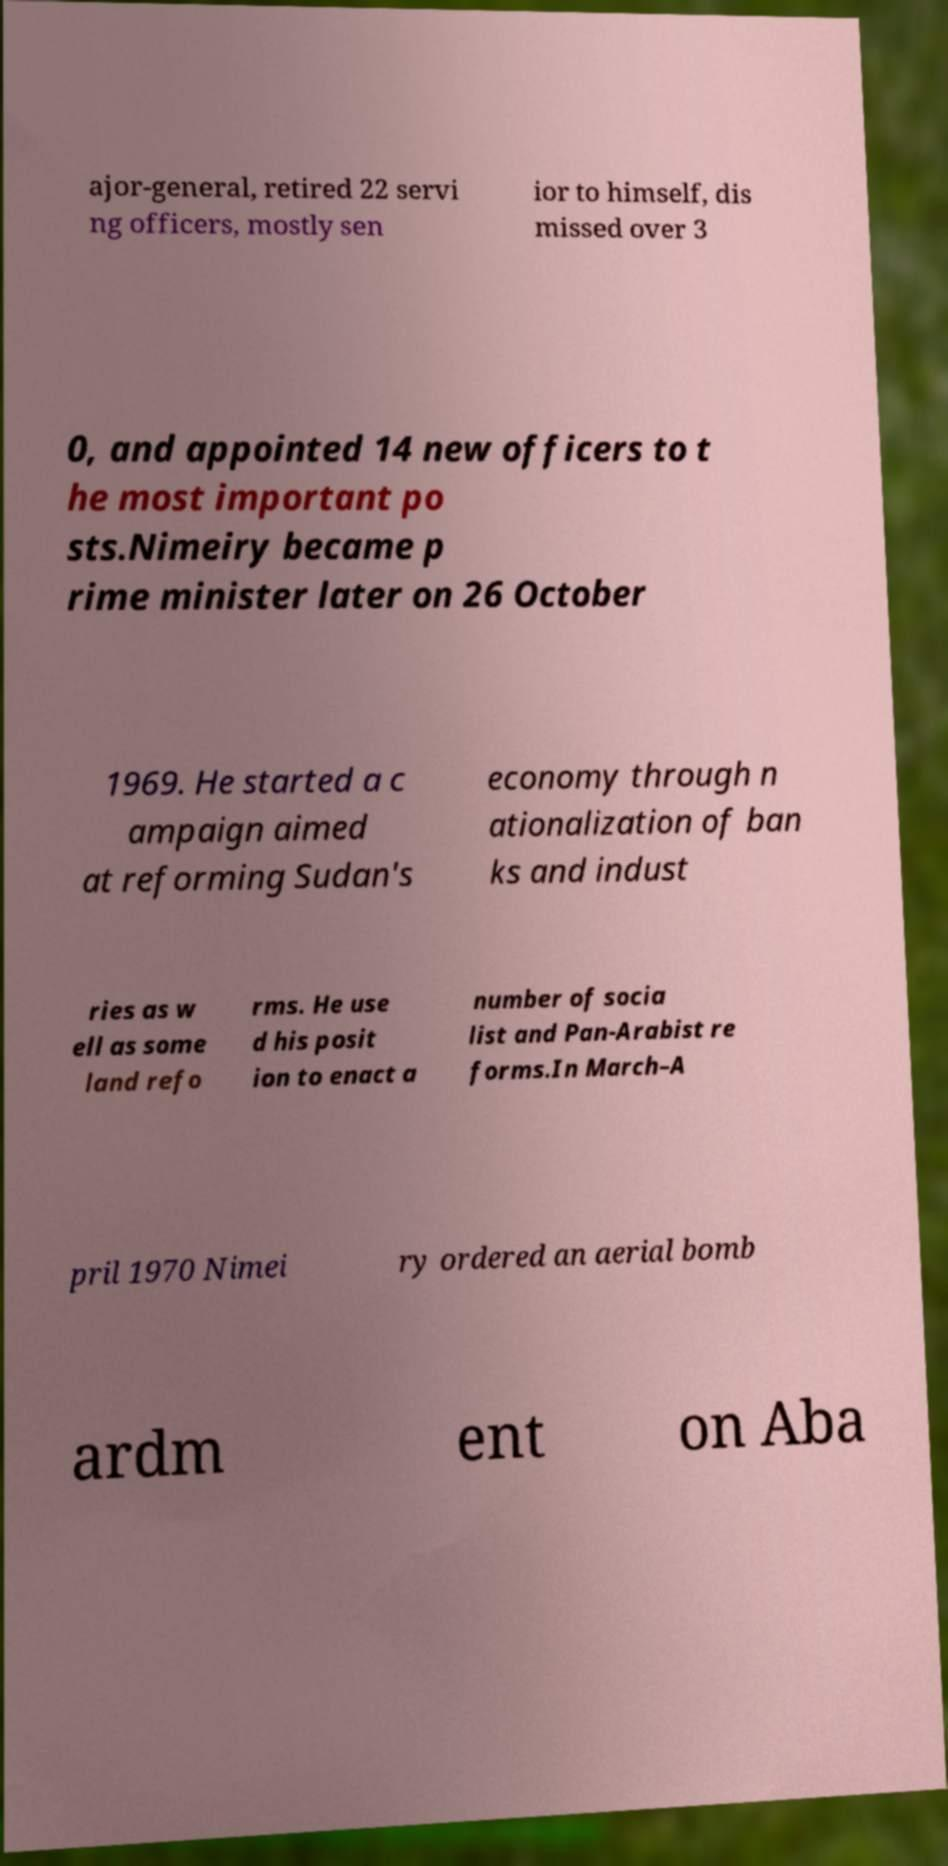What messages or text are displayed in this image? I need them in a readable, typed format. ajor-general, retired 22 servi ng officers, mostly sen ior to himself, dis missed over 3 0, and appointed 14 new officers to t he most important po sts.Nimeiry became p rime minister later on 26 October 1969. He started a c ampaign aimed at reforming Sudan's economy through n ationalization of ban ks and indust ries as w ell as some land refo rms. He use d his posit ion to enact a number of socia list and Pan-Arabist re forms.In March–A pril 1970 Nimei ry ordered an aerial bomb ardm ent on Aba 